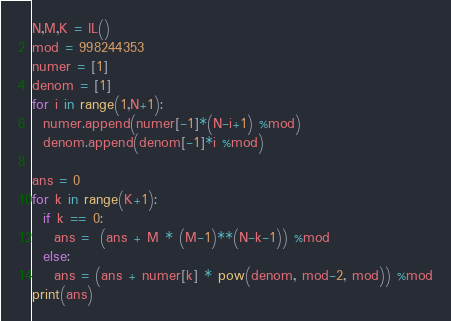Convert code to text. <code><loc_0><loc_0><loc_500><loc_500><_Python_>N,M,K = IL()
mod = 998244353
numer = [1]
denom = [1]
for i in range(1,N+1):
  numer.append(numer[-1]*(N-i+1) %mod)
  denom.append(denom[-1]*i %mod)

ans = 0
for k in range(K+1):
  if k == 0:
    ans =  (ans + M * (M-1)**(N-k-1)) %mod
  else:
    ans = (ans + numer[k] * pow(denom, mod-2, mod)) %mod
print(ans)</code> 